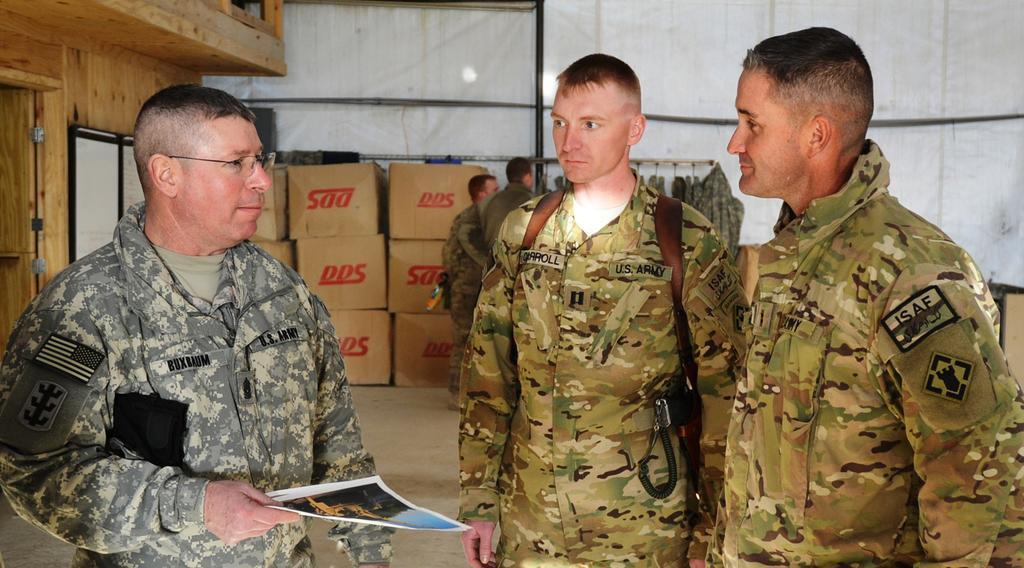Can you describe this image briefly? In this image we can see some people standing. In that a man is holding some papers. On the backside we can see a wooden house, some cardboard boxes and some clothes to a hanger. 